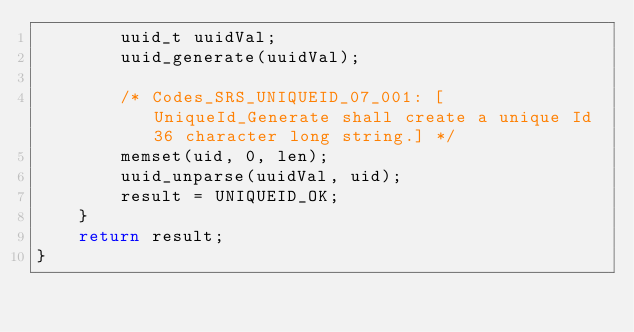Convert code to text. <code><loc_0><loc_0><loc_500><loc_500><_C_>        uuid_t uuidVal;
        uuid_generate(uuidVal);

        /* Codes_SRS_UNIQUEID_07_001: [UniqueId_Generate shall create a unique Id 36 character long string.] */
        memset(uid, 0, len);
        uuid_unparse(uuidVal, uid);
        result = UNIQUEID_OK;
    }
    return result;
}
</code> 